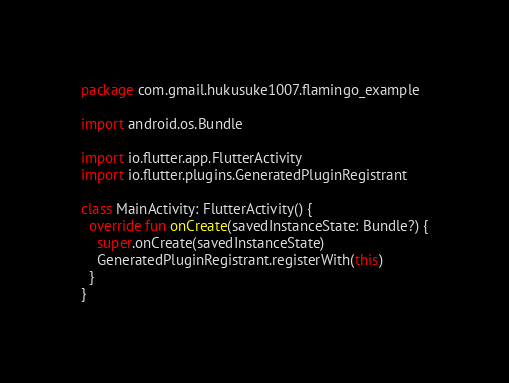Convert code to text. <code><loc_0><loc_0><loc_500><loc_500><_Kotlin_>package com.gmail.hukusuke1007.flamingo_example

import android.os.Bundle

import io.flutter.app.FlutterActivity
import io.flutter.plugins.GeneratedPluginRegistrant

class MainActivity: FlutterActivity() {
  override fun onCreate(savedInstanceState: Bundle?) {
    super.onCreate(savedInstanceState)
    GeneratedPluginRegistrant.registerWith(this)
  }
}
</code> 